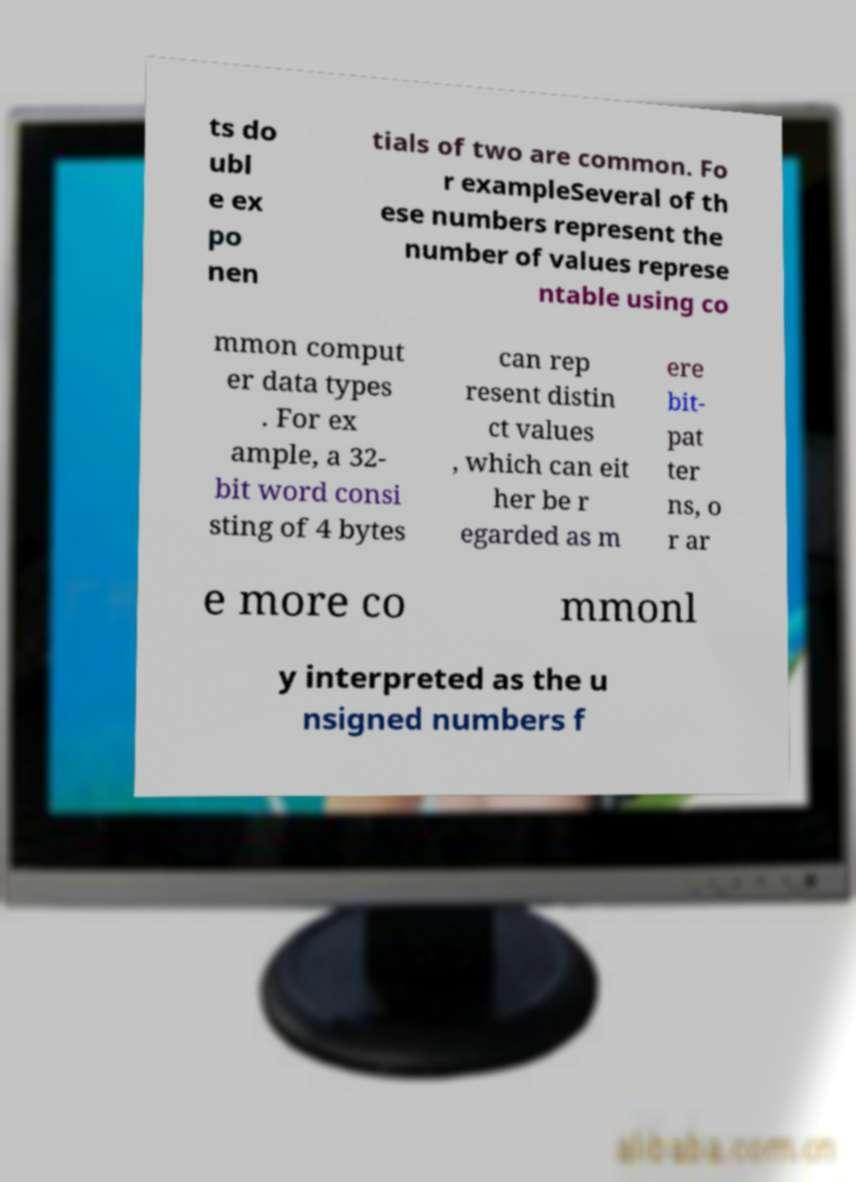Please read and relay the text visible in this image. What does it say? ts do ubl e ex po nen tials of two are common. Fo r exampleSeveral of th ese numbers represent the number of values represe ntable using co mmon comput er data types . For ex ample, a 32- bit word consi sting of 4 bytes can rep resent distin ct values , which can eit her be r egarded as m ere bit- pat ter ns, o r ar e more co mmonl y interpreted as the u nsigned numbers f 